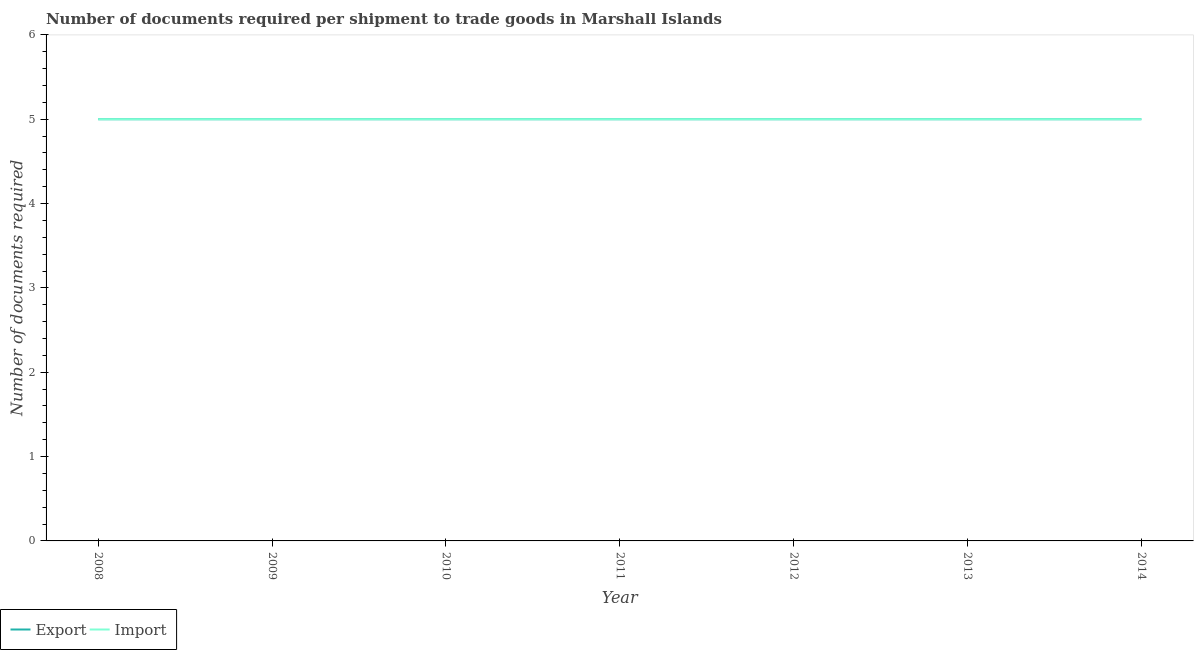Does the line corresponding to number of documents required to export goods intersect with the line corresponding to number of documents required to import goods?
Your response must be concise. Yes. Is the number of lines equal to the number of legend labels?
Provide a succinct answer. Yes. What is the number of documents required to export goods in 2008?
Your answer should be very brief. 5. Across all years, what is the maximum number of documents required to import goods?
Give a very brief answer. 5. Across all years, what is the minimum number of documents required to export goods?
Your response must be concise. 5. In which year was the number of documents required to export goods maximum?
Make the answer very short. 2008. What is the total number of documents required to export goods in the graph?
Ensure brevity in your answer.  35. What is the difference between the number of documents required to export goods in 2009 and that in 2012?
Make the answer very short. 0. In how many years, is the number of documents required to import goods greater than 1.4?
Provide a succinct answer. 7. What is the ratio of the number of documents required to import goods in 2009 to that in 2010?
Provide a succinct answer. 1. In how many years, is the number of documents required to export goods greater than the average number of documents required to export goods taken over all years?
Give a very brief answer. 0. Does the number of documents required to import goods monotonically increase over the years?
Offer a very short reply. No. Is the number of documents required to import goods strictly less than the number of documents required to export goods over the years?
Your answer should be very brief. No. How many lines are there?
Provide a short and direct response. 2. How many years are there in the graph?
Make the answer very short. 7. Are the values on the major ticks of Y-axis written in scientific E-notation?
Your answer should be compact. No. Does the graph contain any zero values?
Provide a succinct answer. No. Where does the legend appear in the graph?
Your answer should be very brief. Bottom left. How are the legend labels stacked?
Provide a short and direct response. Horizontal. What is the title of the graph?
Offer a terse response. Number of documents required per shipment to trade goods in Marshall Islands. Does "Private consumption" appear as one of the legend labels in the graph?
Offer a very short reply. No. What is the label or title of the X-axis?
Offer a very short reply. Year. What is the label or title of the Y-axis?
Provide a short and direct response. Number of documents required. What is the Number of documents required in Import in 2008?
Your answer should be very brief. 5. What is the Number of documents required of Import in 2009?
Offer a terse response. 5. What is the Number of documents required in Export in 2010?
Your answer should be very brief. 5. What is the Number of documents required of Import in 2011?
Your response must be concise. 5. What is the Number of documents required in Export in 2012?
Your answer should be compact. 5. What is the Number of documents required of Import in 2013?
Provide a short and direct response. 5. What is the Number of documents required in Export in 2014?
Provide a short and direct response. 5. What is the Number of documents required in Import in 2014?
Offer a terse response. 5. Across all years, what is the maximum Number of documents required of Export?
Ensure brevity in your answer.  5. Across all years, what is the maximum Number of documents required of Import?
Offer a very short reply. 5. Across all years, what is the minimum Number of documents required in Export?
Provide a short and direct response. 5. What is the total Number of documents required of Export in the graph?
Your answer should be compact. 35. What is the total Number of documents required of Import in the graph?
Your response must be concise. 35. What is the difference between the Number of documents required in Import in 2008 and that in 2009?
Make the answer very short. 0. What is the difference between the Number of documents required in Import in 2008 and that in 2010?
Make the answer very short. 0. What is the difference between the Number of documents required in Import in 2008 and that in 2011?
Offer a very short reply. 0. What is the difference between the Number of documents required in Import in 2008 and that in 2013?
Ensure brevity in your answer.  0. What is the difference between the Number of documents required of Import in 2009 and that in 2010?
Ensure brevity in your answer.  0. What is the difference between the Number of documents required of Export in 2009 and that in 2011?
Your answer should be compact. 0. What is the difference between the Number of documents required in Import in 2009 and that in 2011?
Ensure brevity in your answer.  0. What is the difference between the Number of documents required in Export in 2009 and that in 2012?
Offer a terse response. 0. What is the difference between the Number of documents required of Import in 2009 and that in 2013?
Ensure brevity in your answer.  0. What is the difference between the Number of documents required of Import in 2009 and that in 2014?
Provide a short and direct response. 0. What is the difference between the Number of documents required in Export in 2010 and that in 2012?
Keep it short and to the point. 0. What is the difference between the Number of documents required of Export in 2010 and that in 2013?
Your answer should be very brief. 0. What is the difference between the Number of documents required of Import in 2010 and that in 2013?
Keep it short and to the point. 0. What is the difference between the Number of documents required of Export in 2011 and that in 2012?
Ensure brevity in your answer.  0. What is the difference between the Number of documents required in Import in 2011 and that in 2012?
Offer a very short reply. 0. What is the difference between the Number of documents required in Export in 2011 and that in 2014?
Provide a succinct answer. 0. What is the difference between the Number of documents required of Export in 2012 and that in 2013?
Your answer should be very brief. 0. What is the difference between the Number of documents required of Import in 2012 and that in 2013?
Make the answer very short. 0. What is the difference between the Number of documents required of Export in 2012 and that in 2014?
Your answer should be compact. 0. What is the difference between the Number of documents required in Import in 2012 and that in 2014?
Your answer should be compact. 0. What is the difference between the Number of documents required in Export in 2008 and the Number of documents required in Import in 2011?
Make the answer very short. 0. What is the difference between the Number of documents required in Export in 2009 and the Number of documents required in Import in 2010?
Offer a very short reply. 0. What is the difference between the Number of documents required in Export in 2009 and the Number of documents required in Import in 2013?
Provide a succinct answer. 0. What is the difference between the Number of documents required of Export in 2010 and the Number of documents required of Import in 2012?
Keep it short and to the point. 0. What is the difference between the Number of documents required in Export in 2010 and the Number of documents required in Import in 2014?
Offer a terse response. 0. What is the average Number of documents required in Export per year?
Make the answer very short. 5. In the year 2008, what is the difference between the Number of documents required in Export and Number of documents required in Import?
Make the answer very short. 0. In the year 2009, what is the difference between the Number of documents required of Export and Number of documents required of Import?
Your response must be concise. 0. What is the ratio of the Number of documents required in Import in 2008 to that in 2009?
Make the answer very short. 1. What is the ratio of the Number of documents required of Export in 2008 to that in 2010?
Provide a succinct answer. 1. What is the ratio of the Number of documents required in Import in 2008 to that in 2011?
Your answer should be very brief. 1. What is the ratio of the Number of documents required of Export in 2008 to that in 2012?
Keep it short and to the point. 1. What is the ratio of the Number of documents required in Import in 2008 to that in 2012?
Give a very brief answer. 1. What is the ratio of the Number of documents required in Import in 2008 to that in 2013?
Make the answer very short. 1. What is the ratio of the Number of documents required in Export in 2008 to that in 2014?
Your answer should be very brief. 1. What is the ratio of the Number of documents required in Export in 2009 to that in 2010?
Provide a succinct answer. 1. What is the ratio of the Number of documents required in Import in 2009 to that in 2011?
Make the answer very short. 1. What is the ratio of the Number of documents required of Export in 2009 to that in 2014?
Give a very brief answer. 1. What is the ratio of the Number of documents required of Import in 2009 to that in 2014?
Make the answer very short. 1. What is the ratio of the Number of documents required of Export in 2010 to that in 2011?
Offer a terse response. 1. What is the ratio of the Number of documents required of Import in 2010 to that in 2013?
Provide a short and direct response. 1. What is the ratio of the Number of documents required in Export in 2010 to that in 2014?
Provide a succinct answer. 1. What is the ratio of the Number of documents required of Export in 2011 to that in 2012?
Ensure brevity in your answer.  1. What is the ratio of the Number of documents required in Import in 2011 to that in 2013?
Provide a short and direct response. 1. What is the ratio of the Number of documents required in Export in 2011 to that in 2014?
Make the answer very short. 1. What is the ratio of the Number of documents required of Import in 2011 to that in 2014?
Your answer should be very brief. 1. What is the ratio of the Number of documents required in Export in 2012 to that in 2013?
Your response must be concise. 1. What is the ratio of the Number of documents required in Import in 2012 to that in 2013?
Provide a short and direct response. 1. What is the ratio of the Number of documents required of Export in 2012 to that in 2014?
Provide a succinct answer. 1. What is the ratio of the Number of documents required of Import in 2012 to that in 2014?
Your response must be concise. 1. What is the difference between the highest and the lowest Number of documents required in Export?
Offer a terse response. 0. 